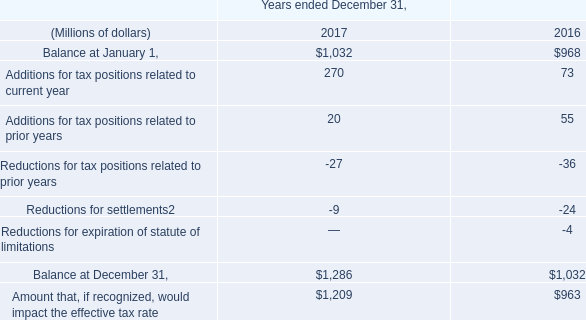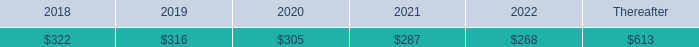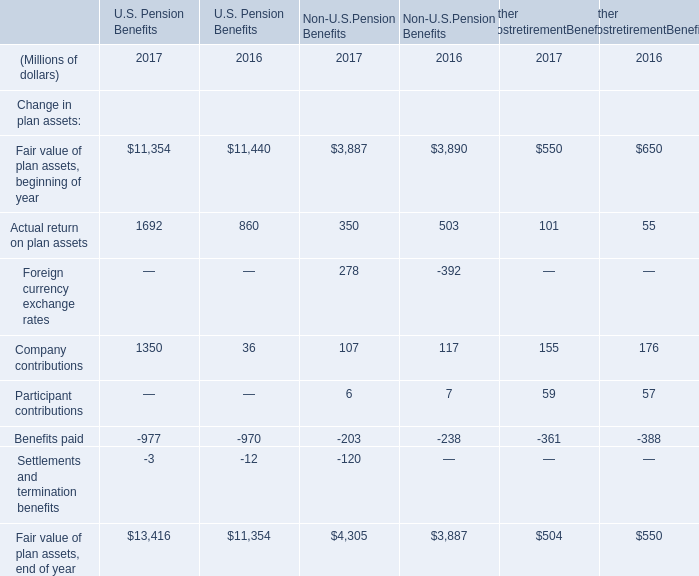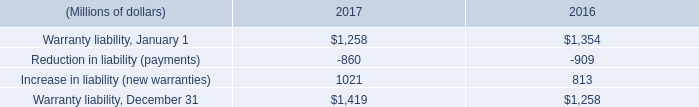what is the 2017 growth rate in the amount of the unused commitments and lines of credit for dealers? 
Computations: ((10993 - 12775) / 12775)
Answer: -0.13949. 